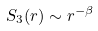<formula> <loc_0><loc_0><loc_500><loc_500>S _ { 3 } ( r ) \sim r ^ { - \beta }</formula> 